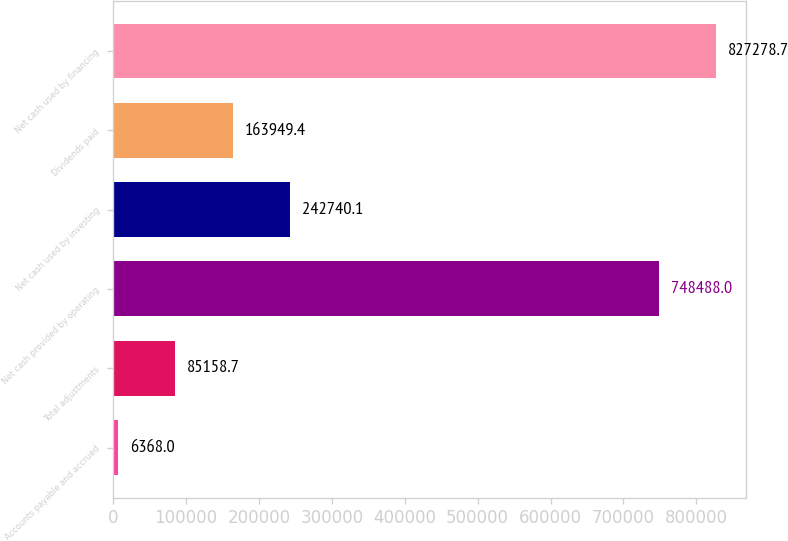<chart> <loc_0><loc_0><loc_500><loc_500><bar_chart><fcel>Accounts payable and accrued<fcel>Total adjustments<fcel>Net cash provided by operating<fcel>Net cash used by investing<fcel>Dividends paid<fcel>Net cash used by financing<nl><fcel>6368<fcel>85158.7<fcel>748488<fcel>242740<fcel>163949<fcel>827279<nl></chart> 